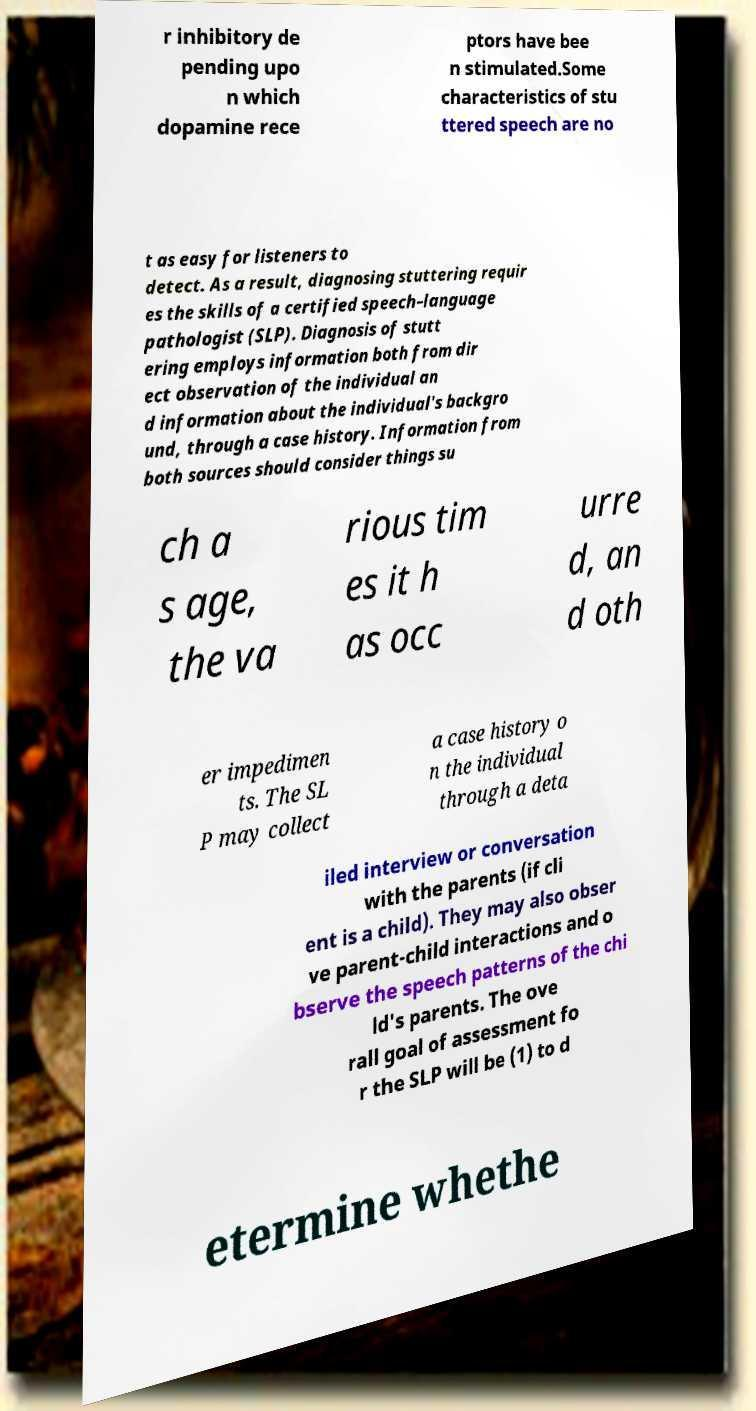Can you read and provide the text displayed in the image?This photo seems to have some interesting text. Can you extract and type it out for me? r inhibitory de pending upo n which dopamine rece ptors have bee n stimulated.Some characteristics of stu ttered speech are no t as easy for listeners to detect. As a result, diagnosing stuttering requir es the skills of a certified speech–language pathologist (SLP). Diagnosis of stutt ering employs information both from dir ect observation of the individual an d information about the individual's backgro und, through a case history. Information from both sources should consider things su ch a s age, the va rious tim es it h as occ urre d, an d oth er impedimen ts. The SL P may collect a case history o n the individual through a deta iled interview or conversation with the parents (if cli ent is a child). They may also obser ve parent-child interactions and o bserve the speech patterns of the chi ld's parents. The ove rall goal of assessment fo r the SLP will be (1) to d etermine whethe 